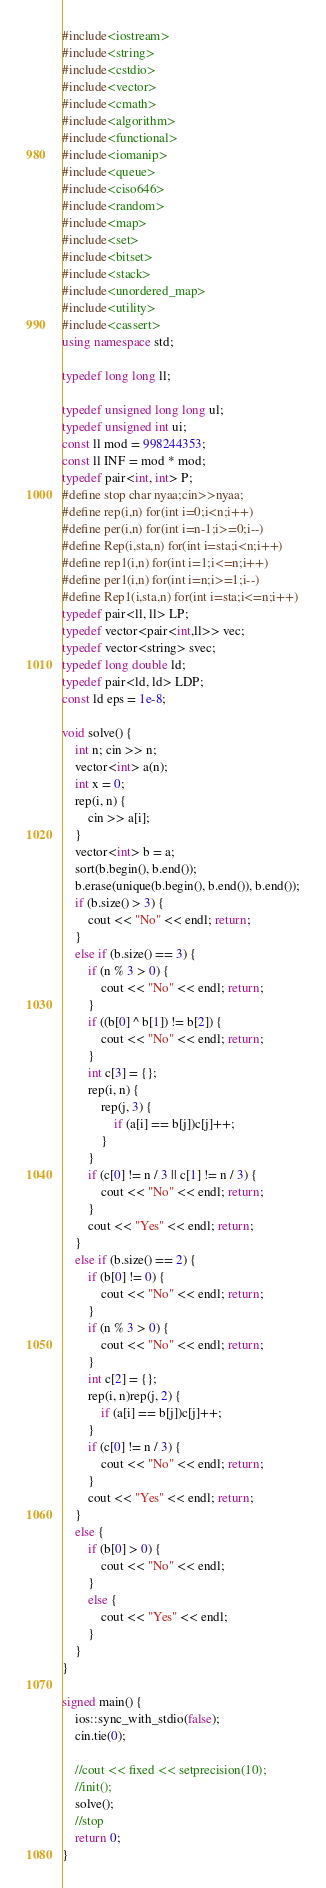<code> <loc_0><loc_0><loc_500><loc_500><_C++_>#include<iostream>
#include<string>
#include<cstdio>
#include<vector>
#include<cmath>
#include<algorithm>
#include<functional>
#include<iomanip>
#include<queue>
#include<ciso646>
#include<random>
#include<map>
#include<set>
#include<bitset>
#include<stack>
#include<unordered_map>
#include<utility>
#include<cassert>
using namespace std;

typedef long long ll;

typedef unsigned long long ul;
typedef unsigned int ui;
const ll mod = 998244353;
const ll INF = mod * mod;
typedef pair<int, int> P;
#define stop char nyaa;cin>>nyaa;
#define rep(i,n) for(int i=0;i<n;i++)
#define per(i,n) for(int i=n-1;i>=0;i--)
#define Rep(i,sta,n) for(int i=sta;i<n;i++)
#define rep1(i,n) for(int i=1;i<=n;i++)
#define per1(i,n) for(int i=n;i>=1;i--)
#define Rep1(i,sta,n) for(int i=sta;i<=n;i++)
typedef pair<ll, ll> LP;
typedef vector<pair<int,ll>> vec;
typedef vector<string> svec;
typedef long double ld;
typedef pair<ld, ld> LDP;
const ld eps = 1e-8;

void solve() {
	int n; cin >> n;
	vector<int> a(n);
	int x = 0;
	rep(i, n) {
		cin >> a[i];
	}
	vector<int> b = a;
	sort(b.begin(), b.end());
	b.erase(unique(b.begin(), b.end()), b.end());
	if (b.size() > 3) {
		cout << "No" << endl; return;
	}
	else if (b.size() == 3) {
		if (n % 3 > 0) {
			cout << "No" << endl; return;
		}
		if ((b[0] ^ b[1]) != b[2]) {
			cout << "No" << endl; return;
		}
		int c[3] = {};
		rep(i, n) {
			rep(j, 3) {
				if (a[i] == b[j])c[j]++;
			}
		}
		if (c[0] != n / 3 || c[1] != n / 3) {
			cout << "No" << endl; return;
		}
		cout << "Yes" << endl; return;
	}
	else if (b.size() == 2) {
		if (b[0] != 0) {
			cout << "No" << endl; return;
		}
		if (n % 3 > 0) {
			cout << "No" << endl; return;
		}
		int c[2] = {};
		rep(i, n)rep(j, 2) {
			if (a[i] == b[j])c[j]++;
		}
		if (c[0] != n / 3) {
			cout << "No" << endl; return;
		}
		cout << "Yes" << endl; return;
	}
	else {
		if (b[0] > 0) {
			cout << "No" << endl;
		}
		else {
			cout << "Yes" << endl;
		}
	}
}

signed main() {
	ios::sync_with_stdio(false);
	cin.tie(0);

	//cout << fixed << setprecision(10);
	//init();
	solve();
	//stop
	return 0;
}

</code> 